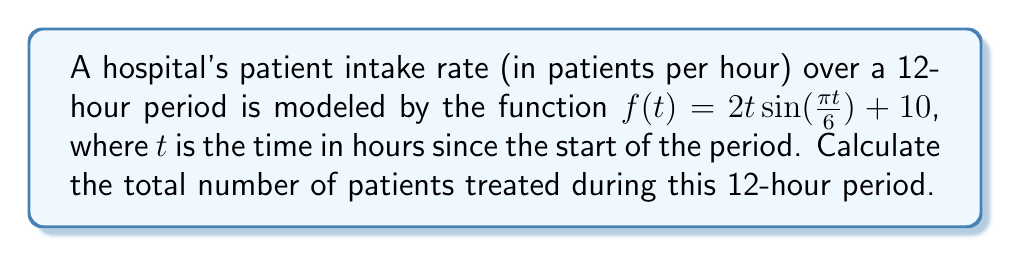What is the answer to this math problem? To find the total number of patients treated during the 12-hour period, we need to evaluate the definite integral of the patient intake rate function over the given time interval. Here's how we can approach this problem:

1) The function representing the patient intake rate is:
   $f(t) = 2t\sin(\frac{\pi t}{6}) + 10$

2) We need to integrate this function from $t=0$ to $t=12$:
   $$\int_0^{12} (2t\sin(\frac{\pi t}{6}) + 10) dt$$

3) Let's split this into two integrals:
   $$\int_0^{12} 2t\sin(\frac{\pi t}{6}) dt + \int_0^{12} 10 dt$$

4) The second integral is straightforward:
   $$\int_0^{12} 10 dt = 10t \bigg|_0^{12} = 120$$

5) For the first integral, we can use integration by parts. Let:
   $u = t$, $du = dt$
   $dv = 2\sin(\frac{\pi t}{6}) dt$, $v = -\frac{12}{\pi}\cos(\frac{\pi t}{6})$

   $$\int_0^{12} 2t\sin(\frac{\pi t}{6}) dt = -\frac{12}{\pi}t\cos(\frac{\pi t}{6}) \bigg|_0^{12} + \frac{12}{\pi}\int_0^{12} \cos(\frac{\pi t}{6}) dt$$

6) Evaluating the first term:
   $-\frac{12}{\pi}t\cos(\frac{\pi t}{6}) \bigg|_0^{12} = -\frac{12}{\pi}(12\cos(2\pi) - 0) = -\frac{144}{\pi}$

7) For the second term:
   $\frac{12}{\pi}\int_0^{12} \cos(\frac{\pi t}{6}) dt = \frac{12}{\pi} \cdot \frac{6}{\pi}\sin(\frac{\pi t}{6}) \bigg|_0^{12} = \frac{72}{\pi^2}(0 - 0) = 0$

8) Combining all parts:
   Total patients = $-\frac{144}{\pi} + 0 + 120 = 120 - \frac{144}{\pi}$

9) Using a calculator to approximate:
   $120 - \frac{144}{\pi} \approx 74.18$

Since we're dealing with patients, we need to round up to the nearest whole number.
Answer: The total number of patients treated during the 12-hour period is approximately 75 patients. 